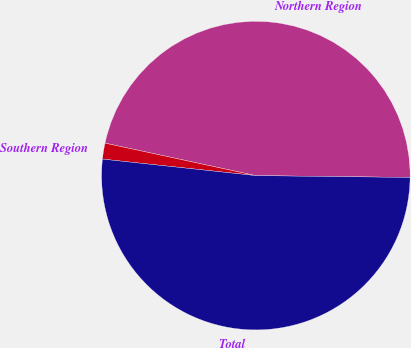Convert chart. <chart><loc_0><loc_0><loc_500><loc_500><pie_chart><fcel>Northern Region<fcel>Southern Region<fcel>Total<nl><fcel>46.81%<fcel>1.67%<fcel>51.52%<nl></chart> 